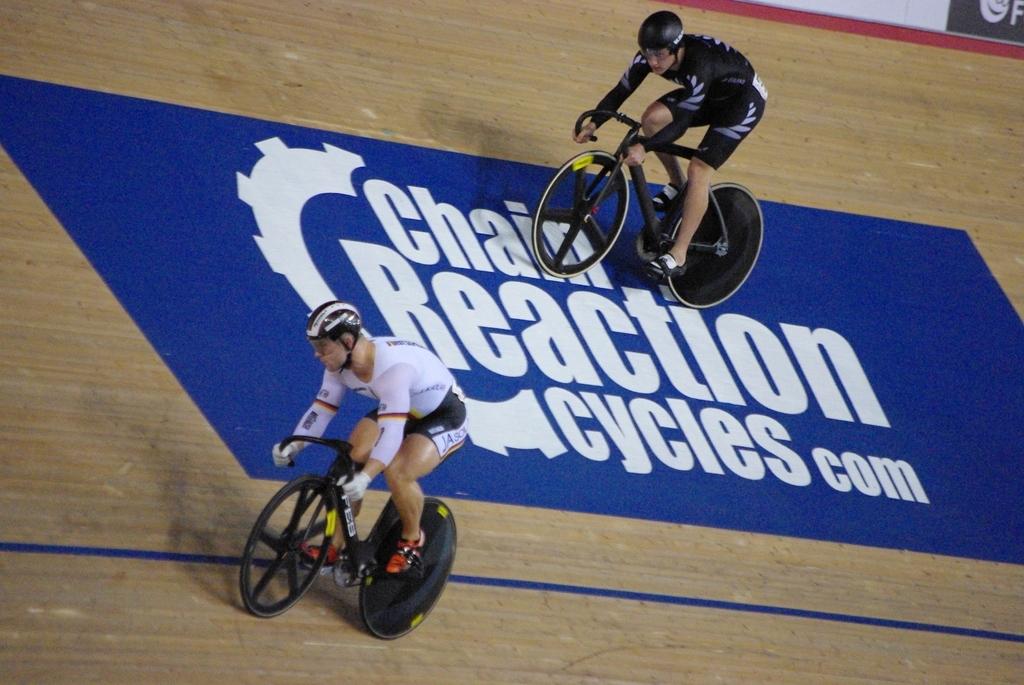What is the website featured on this sing?
Offer a very short reply. Chainreactioncycles.com. How many cyclists can you see?
Offer a terse response. Answering does not require reading text in the image. 